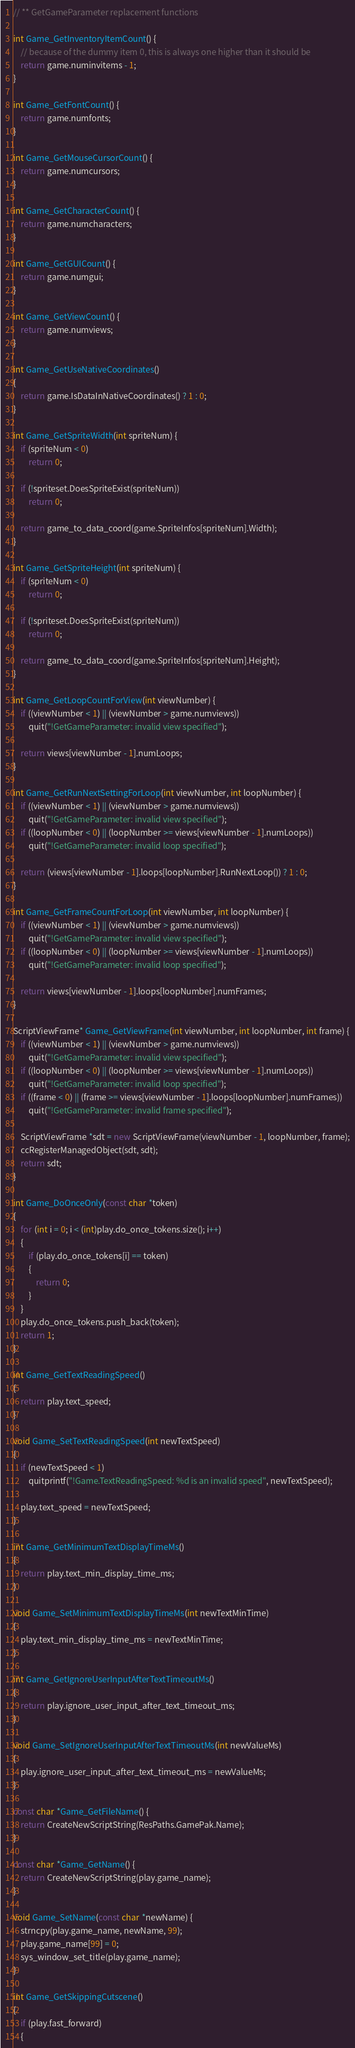Convert code to text. <code><loc_0><loc_0><loc_500><loc_500><_C++_>

// ** GetGameParameter replacement functions

int Game_GetInventoryItemCount() {
    // because of the dummy item 0, this is always one higher than it should be
    return game.numinvitems - 1;
}

int Game_GetFontCount() {
    return game.numfonts;
}

int Game_GetMouseCursorCount() {
    return game.numcursors;
}

int Game_GetCharacterCount() {
    return game.numcharacters;
}

int Game_GetGUICount() {
    return game.numgui;
}

int Game_GetViewCount() {
    return game.numviews;
}

int Game_GetUseNativeCoordinates()
{
    return game.IsDataInNativeCoordinates() ? 1 : 0;
}

int Game_GetSpriteWidth(int spriteNum) {
    if (spriteNum < 0)
        return 0;

    if (!spriteset.DoesSpriteExist(spriteNum))
        return 0;

    return game_to_data_coord(game.SpriteInfos[spriteNum].Width);
}

int Game_GetSpriteHeight(int spriteNum) {
    if (spriteNum < 0)
        return 0;

    if (!spriteset.DoesSpriteExist(spriteNum))
        return 0;

    return game_to_data_coord(game.SpriteInfos[spriteNum].Height);
}

int Game_GetLoopCountForView(int viewNumber) {
    if ((viewNumber < 1) || (viewNumber > game.numviews))
        quit("!GetGameParameter: invalid view specified");

    return views[viewNumber - 1].numLoops;
}

int Game_GetRunNextSettingForLoop(int viewNumber, int loopNumber) {
    if ((viewNumber < 1) || (viewNumber > game.numviews))
        quit("!GetGameParameter: invalid view specified");
    if ((loopNumber < 0) || (loopNumber >= views[viewNumber - 1].numLoops))
        quit("!GetGameParameter: invalid loop specified");

    return (views[viewNumber - 1].loops[loopNumber].RunNextLoop()) ? 1 : 0;
}

int Game_GetFrameCountForLoop(int viewNumber, int loopNumber) {
    if ((viewNumber < 1) || (viewNumber > game.numviews))
        quit("!GetGameParameter: invalid view specified");
    if ((loopNumber < 0) || (loopNumber >= views[viewNumber - 1].numLoops))
        quit("!GetGameParameter: invalid loop specified");

    return views[viewNumber - 1].loops[loopNumber].numFrames;
}

ScriptViewFrame* Game_GetViewFrame(int viewNumber, int loopNumber, int frame) {
    if ((viewNumber < 1) || (viewNumber > game.numviews))
        quit("!GetGameParameter: invalid view specified");
    if ((loopNumber < 0) || (loopNumber >= views[viewNumber - 1].numLoops))
        quit("!GetGameParameter: invalid loop specified");
    if ((frame < 0) || (frame >= views[viewNumber - 1].loops[loopNumber].numFrames))
        quit("!GetGameParameter: invalid frame specified");

    ScriptViewFrame *sdt = new ScriptViewFrame(viewNumber - 1, loopNumber, frame);
    ccRegisterManagedObject(sdt, sdt);
    return sdt;
}

int Game_DoOnceOnly(const char *token)
{
    for (int i = 0; i < (int)play.do_once_tokens.size(); i++)
    {
        if (play.do_once_tokens[i] == token)
        {
            return 0;
        }
    }
    play.do_once_tokens.push_back(token);
    return 1;
}

int Game_GetTextReadingSpeed()
{
    return play.text_speed;
}

void Game_SetTextReadingSpeed(int newTextSpeed)
{
    if (newTextSpeed < 1)
        quitprintf("!Game.TextReadingSpeed: %d is an invalid speed", newTextSpeed);

    play.text_speed = newTextSpeed;
}

int Game_GetMinimumTextDisplayTimeMs()
{
    return play.text_min_display_time_ms;
}

void Game_SetMinimumTextDisplayTimeMs(int newTextMinTime)
{
    play.text_min_display_time_ms = newTextMinTime;
}

int Game_GetIgnoreUserInputAfterTextTimeoutMs()
{
    return play.ignore_user_input_after_text_timeout_ms;
}

void Game_SetIgnoreUserInputAfterTextTimeoutMs(int newValueMs)
{
    play.ignore_user_input_after_text_timeout_ms = newValueMs;
}

const char *Game_GetFileName() {
    return CreateNewScriptString(ResPaths.GamePak.Name);
}

const char *Game_GetName() {
    return CreateNewScriptString(play.game_name);
}

void Game_SetName(const char *newName) {
    strncpy(play.game_name, newName, 99);
    play.game_name[99] = 0;
    sys_window_set_title(play.game_name);
}

int Game_GetSkippingCutscene()
{
    if (play.fast_forward)
    {</code> 